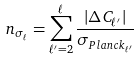Convert formula to latex. <formula><loc_0><loc_0><loc_500><loc_500>n _ { \sigma _ { \ell } } = \sum _ { \ell ^ { \prime } = 2 } ^ { \ell } \frac { | \Delta C _ { \ell ^ { \prime } } | } { \sigma _ { P l a n c k _ { \ell ^ { \prime } } } }</formula> 